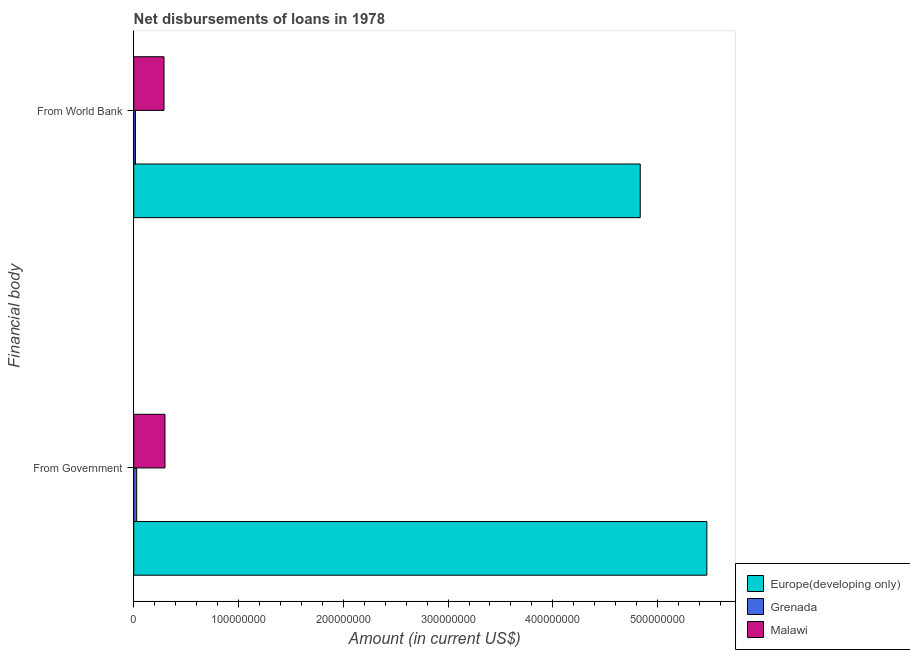How many different coloured bars are there?
Offer a terse response. 3. How many groups of bars are there?
Your response must be concise. 2. How many bars are there on the 2nd tick from the top?
Your answer should be compact. 3. What is the label of the 1st group of bars from the top?
Make the answer very short. From World Bank. What is the net disbursements of loan from world bank in Europe(developing only)?
Provide a succinct answer. 4.83e+08. Across all countries, what is the maximum net disbursements of loan from world bank?
Offer a terse response. 4.83e+08. Across all countries, what is the minimum net disbursements of loan from world bank?
Ensure brevity in your answer.  1.63e+06. In which country was the net disbursements of loan from world bank maximum?
Give a very brief answer. Europe(developing only). In which country was the net disbursements of loan from government minimum?
Provide a short and direct response. Grenada. What is the total net disbursements of loan from government in the graph?
Your answer should be very brief. 5.80e+08. What is the difference between the net disbursements of loan from world bank in Europe(developing only) and that in Malawi?
Give a very brief answer. 4.55e+08. What is the difference between the net disbursements of loan from government in Grenada and the net disbursements of loan from world bank in Malawi?
Offer a very short reply. -2.61e+07. What is the average net disbursements of loan from world bank per country?
Offer a very short reply. 1.71e+08. What is the difference between the net disbursements of loan from government and net disbursements of loan from world bank in Grenada?
Your answer should be very brief. 1.16e+06. In how many countries, is the net disbursements of loan from government greater than 80000000 US$?
Give a very brief answer. 1. What is the ratio of the net disbursements of loan from government in Grenada to that in Malawi?
Give a very brief answer. 0.09. In how many countries, is the net disbursements of loan from government greater than the average net disbursements of loan from government taken over all countries?
Give a very brief answer. 1. What does the 2nd bar from the top in From Government represents?
Give a very brief answer. Grenada. What does the 1st bar from the bottom in From Government represents?
Your answer should be very brief. Europe(developing only). Are all the bars in the graph horizontal?
Your response must be concise. Yes. How many countries are there in the graph?
Provide a succinct answer. 3. How are the legend labels stacked?
Make the answer very short. Vertical. What is the title of the graph?
Make the answer very short. Net disbursements of loans in 1978. Does "Albania" appear as one of the legend labels in the graph?
Make the answer very short. No. What is the label or title of the X-axis?
Offer a terse response. Amount (in current US$). What is the label or title of the Y-axis?
Your answer should be very brief. Financial body. What is the Amount (in current US$) in Europe(developing only) in From Government?
Provide a short and direct response. 5.47e+08. What is the Amount (in current US$) of Grenada in From Government?
Keep it short and to the point. 2.79e+06. What is the Amount (in current US$) in Malawi in From Government?
Offer a terse response. 2.98e+07. What is the Amount (in current US$) of Europe(developing only) in From World Bank?
Make the answer very short. 4.83e+08. What is the Amount (in current US$) in Grenada in From World Bank?
Keep it short and to the point. 1.63e+06. What is the Amount (in current US$) of Malawi in From World Bank?
Provide a succinct answer. 2.89e+07. Across all Financial body, what is the maximum Amount (in current US$) in Europe(developing only)?
Offer a very short reply. 5.47e+08. Across all Financial body, what is the maximum Amount (in current US$) of Grenada?
Offer a terse response. 2.79e+06. Across all Financial body, what is the maximum Amount (in current US$) in Malawi?
Keep it short and to the point. 2.98e+07. Across all Financial body, what is the minimum Amount (in current US$) of Europe(developing only)?
Ensure brevity in your answer.  4.83e+08. Across all Financial body, what is the minimum Amount (in current US$) of Grenada?
Offer a terse response. 1.63e+06. Across all Financial body, what is the minimum Amount (in current US$) in Malawi?
Provide a short and direct response. 2.89e+07. What is the total Amount (in current US$) of Europe(developing only) in the graph?
Provide a succinct answer. 1.03e+09. What is the total Amount (in current US$) in Grenada in the graph?
Your response must be concise. 4.42e+06. What is the total Amount (in current US$) in Malawi in the graph?
Make the answer very short. 5.87e+07. What is the difference between the Amount (in current US$) of Europe(developing only) in From Government and that in From World Bank?
Make the answer very short. 6.36e+07. What is the difference between the Amount (in current US$) of Grenada in From Government and that in From World Bank?
Provide a short and direct response. 1.16e+06. What is the difference between the Amount (in current US$) in Malawi in From Government and that in From World Bank?
Offer a terse response. 9.17e+05. What is the difference between the Amount (in current US$) of Europe(developing only) in From Government and the Amount (in current US$) of Grenada in From World Bank?
Offer a terse response. 5.45e+08. What is the difference between the Amount (in current US$) in Europe(developing only) in From Government and the Amount (in current US$) in Malawi in From World Bank?
Your answer should be compact. 5.18e+08. What is the difference between the Amount (in current US$) in Grenada in From Government and the Amount (in current US$) in Malawi in From World Bank?
Your answer should be compact. -2.61e+07. What is the average Amount (in current US$) of Europe(developing only) per Financial body?
Ensure brevity in your answer.  5.15e+08. What is the average Amount (in current US$) in Grenada per Financial body?
Provide a succinct answer. 2.21e+06. What is the average Amount (in current US$) in Malawi per Financial body?
Provide a succinct answer. 2.93e+07. What is the difference between the Amount (in current US$) in Europe(developing only) and Amount (in current US$) in Grenada in From Government?
Offer a terse response. 5.44e+08. What is the difference between the Amount (in current US$) in Europe(developing only) and Amount (in current US$) in Malawi in From Government?
Your response must be concise. 5.17e+08. What is the difference between the Amount (in current US$) in Grenada and Amount (in current US$) in Malawi in From Government?
Make the answer very short. -2.70e+07. What is the difference between the Amount (in current US$) of Europe(developing only) and Amount (in current US$) of Grenada in From World Bank?
Give a very brief answer. 4.82e+08. What is the difference between the Amount (in current US$) in Europe(developing only) and Amount (in current US$) in Malawi in From World Bank?
Give a very brief answer. 4.55e+08. What is the difference between the Amount (in current US$) in Grenada and Amount (in current US$) in Malawi in From World Bank?
Offer a terse response. -2.73e+07. What is the ratio of the Amount (in current US$) of Europe(developing only) in From Government to that in From World Bank?
Keep it short and to the point. 1.13. What is the ratio of the Amount (in current US$) in Grenada in From Government to that in From World Bank?
Keep it short and to the point. 1.71. What is the ratio of the Amount (in current US$) in Malawi in From Government to that in From World Bank?
Ensure brevity in your answer.  1.03. What is the difference between the highest and the second highest Amount (in current US$) of Europe(developing only)?
Make the answer very short. 6.36e+07. What is the difference between the highest and the second highest Amount (in current US$) of Grenada?
Give a very brief answer. 1.16e+06. What is the difference between the highest and the second highest Amount (in current US$) in Malawi?
Give a very brief answer. 9.17e+05. What is the difference between the highest and the lowest Amount (in current US$) of Europe(developing only)?
Give a very brief answer. 6.36e+07. What is the difference between the highest and the lowest Amount (in current US$) of Grenada?
Your answer should be very brief. 1.16e+06. What is the difference between the highest and the lowest Amount (in current US$) in Malawi?
Make the answer very short. 9.17e+05. 